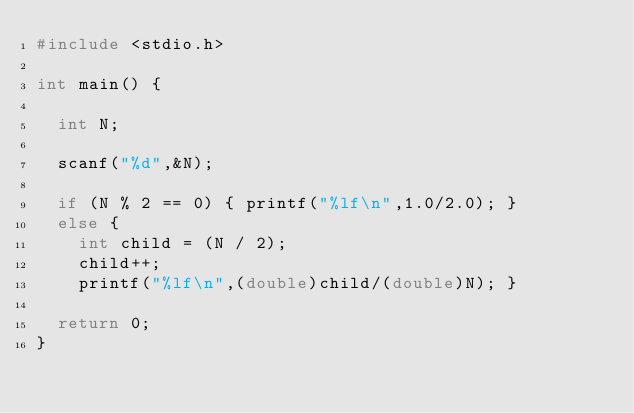<code> <loc_0><loc_0><loc_500><loc_500><_C_>#include <stdio.h>

int main() {

	int N;

	scanf("%d",&N);

	if (N % 2 == 0) { printf("%lf\n",1.0/2.0); }
	else { 
		int child = (N / 2);
		child++;
		printf("%lf\n",(double)child/(double)N); }

	return 0;
}</code> 